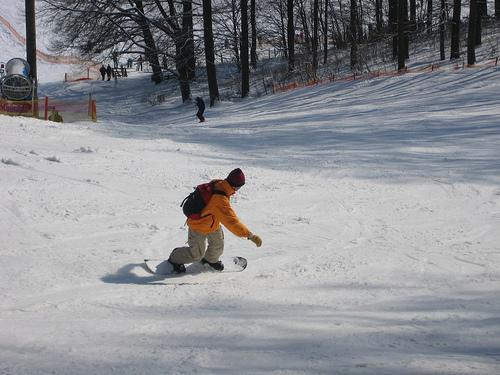Is this person skiing?
Be succinct. No. How many people are in the background?
Be succinct. 5. What on the person carrying on his back?
Keep it brief. Backpack. 